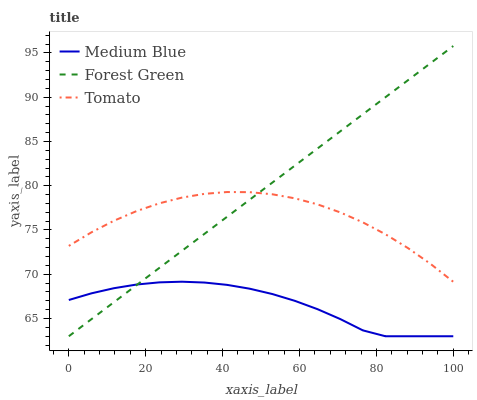Does Medium Blue have the minimum area under the curve?
Answer yes or no. Yes. Does Forest Green have the maximum area under the curve?
Answer yes or no. Yes. Does Forest Green have the minimum area under the curve?
Answer yes or no. No. Does Medium Blue have the maximum area under the curve?
Answer yes or no. No. Is Forest Green the smoothest?
Answer yes or no. Yes. Is Tomato the roughest?
Answer yes or no. Yes. Is Medium Blue the smoothest?
Answer yes or no. No. Is Medium Blue the roughest?
Answer yes or no. No. Does Forest Green have the highest value?
Answer yes or no. Yes. Does Medium Blue have the highest value?
Answer yes or no. No. Is Medium Blue less than Tomato?
Answer yes or no. Yes. Is Tomato greater than Medium Blue?
Answer yes or no. Yes. Does Forest Green intersect Tomato?
Answer yes or no. Yes. Is Forest Green less than Tomato?
Answer yes or no. No. Is Forest Green greater than Tomato?
Answer yes or no. No. Does Medium Blue intersect Tomato?
Answer yes or no. No. 